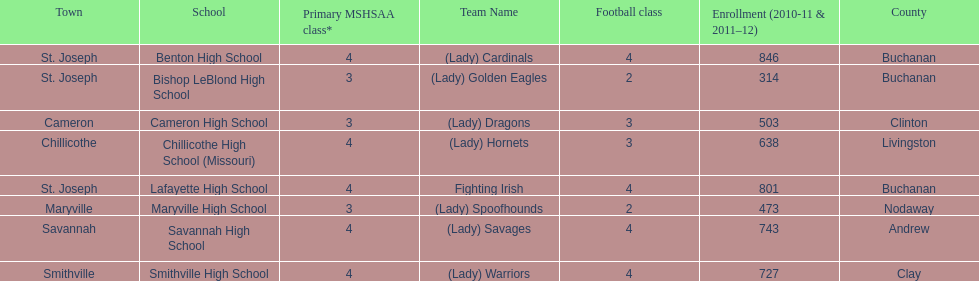How many are enrolled at each school? Benton High School, 846, Bishop LeBlond High School, 314, Cameron High School, 503, Chillicothe High School (Missouri), 638, Lafayette High School, 801, Maryville High School, 473, Savannah High School, 743, Smithville High School, 727. Which school has at only three football classes? Cameron High School, 3, Chillicothe High School (Missouri), 3. Which school has 638 enrolled and 3 football classes? Chillicothe High School (Missouri). 